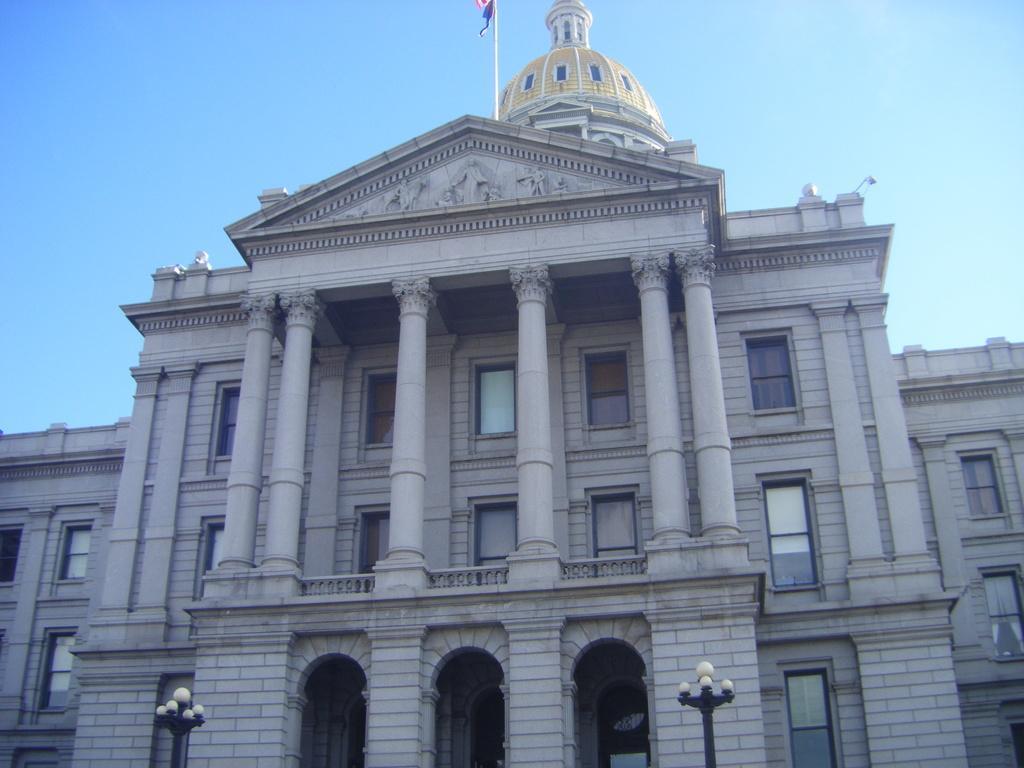Describe this image in one or two sentences. In the picture I can see a white color building which has a flag on it. I can also see street lights and the sky in the background. 